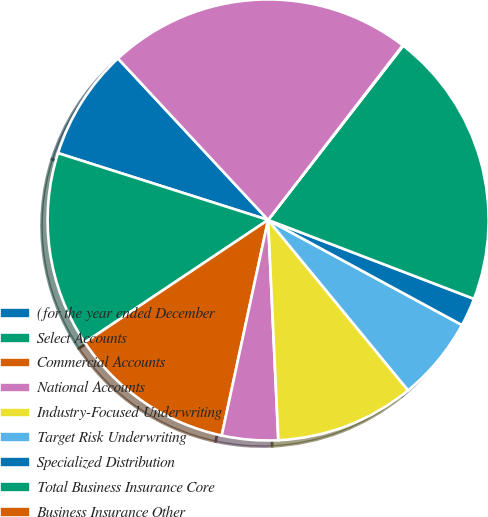<chart> <loc_0><loc_0><loc_500><loc_500><pie_chart><fcel>(for the year ended December<fcel>Select Accounts<fcel>Commercial Accounts<fcel>National Accounts<fcel>Industry-Focused Underwriting<fcel>Target Risk Underwriting<fcel>Specialized Distribution<fcel>Total Business Insurance Core<fcel>Business Insurance Other<fcel>Total Business Insurance<nl><fcel>8.18%<fcel>14.28%<fcel>12.25%<fcel>4.11%<fcel>10.21%<fcel>6.15%<fcel>2.08%<fcel>20.33%<fcel>0.05%<fcel>22.37%<nl></chart> 